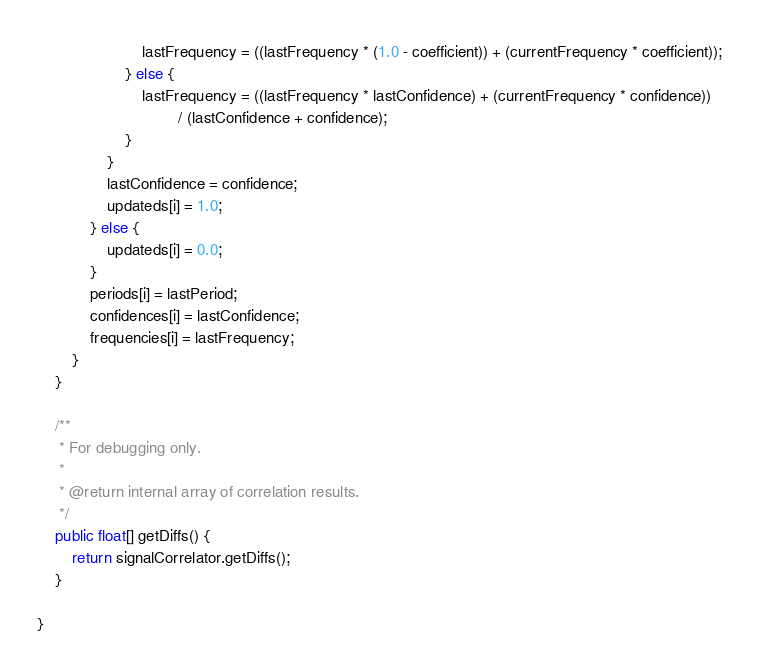Convert code to text. <code><loc_0><loc_0><loc_500><loc_500><_Java_>                        lastFrequency = ((lastFrequency * (1.0 - coefficient)) + (currentFrequency * coefficient));
                    } else {
                        lastFrequency = ((lastFrequency * lastConfidence) + (currentFrequency * confidence))
                                / (lastConfidence + confidence);
                    }
                }
                lastConfidence = confidence;
                updateds[i] = 1.0;
            } else {
                updateds[i] = 0.0;
            }
            periods[i] = lastPeriod;
            confidences[i] = lastConfidence;
            frequencies[i] = lastFrequency;
        }
    }

    /**
     * For debugging only.
     *
     * @return internal array of correlation results.
     */
    public float[] getDiffs() {
        return signalCorrelator.getDiffs();
    }

}
</code> 